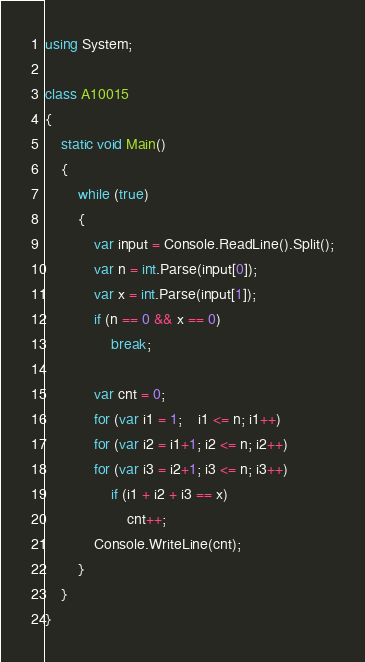<code> <loc_0><loc_0><loc_500><loc_500><_C#_>using System;

class A10015
{
	static void Main()
	{
		while (true)
		{
			var input = Console.ReadLine().Split();
			var n = int.Parse(input[0]);
			var x = int.Parse(input[1]);
			if (n == 0 && x == 0)
				break;

			var cnt = 0;
			for (var i1 = 1;    i1 <= n; i1++)
			for (var i2 = i1+1; i2 <= n; i2++)
			for (var i3 = i2+1; i3 <= n; i3++)
				if (i1 + i2 + i3 == x)
					cnt++;
			Console.WriteLine(cnt);
		}
	}
}</code> 